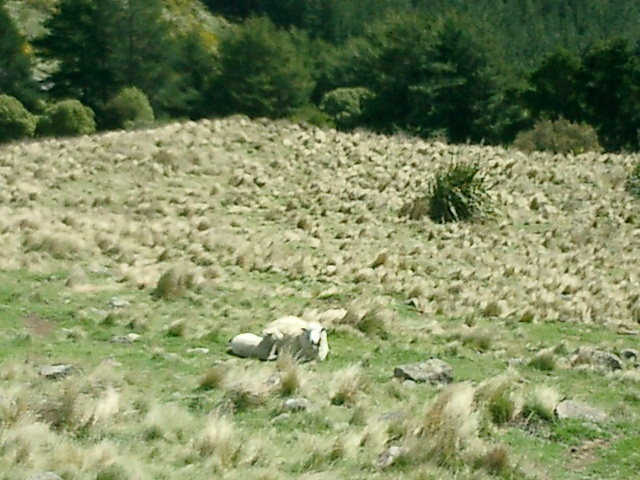Describe the objects in this image and their specific colors. I can see sheep in darkgreen, beige, olive, and gray tones and sheep in darkgreen, gray, beige, and darkgray tones in this image. 